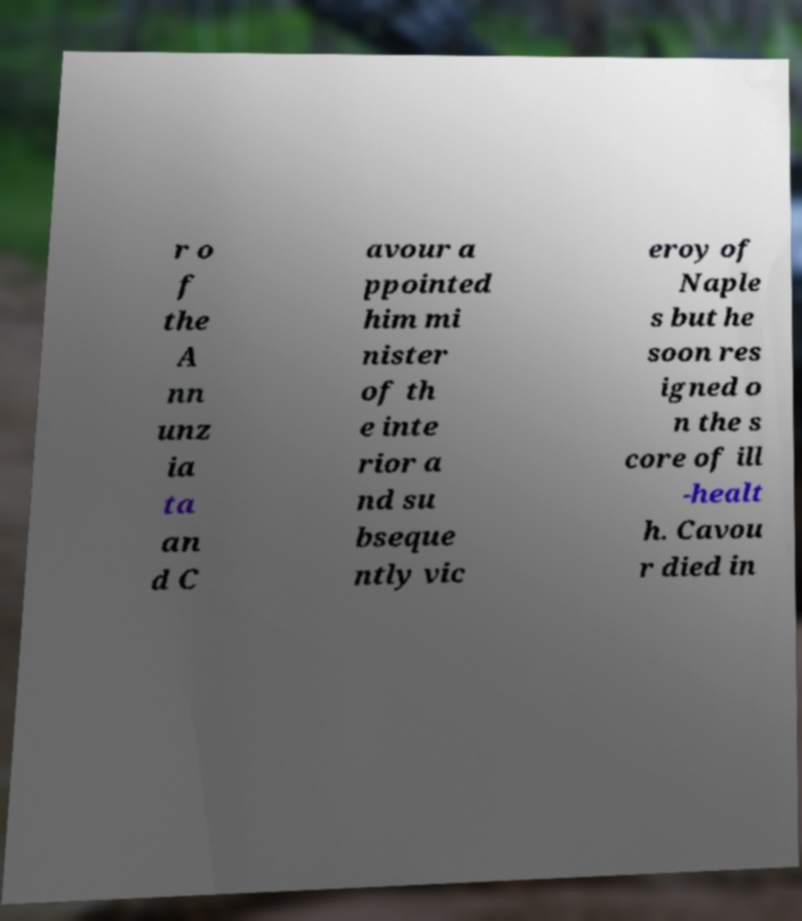I need the written content from this picture converted into text. Can you do that? r o f the A nn unz ia ta an d C avour a ppointed him mi nister of th e inte rior a nd su bseque ntly vic eroy of Naple s but he soon res igned o n the s core of ill -healt h. Cavou r died in 